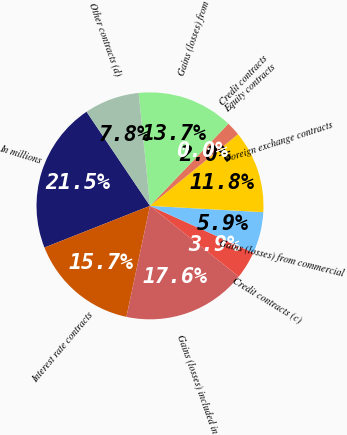Convert chart to OTSL. <chart><loc_0><loc_0><loc_500><loc_500><pie_chart><fcel>In millions<fcel>Interest rate contracts<fcel>Gains (losses) included in<fcel>Credit contracts (c)<fcel>Gains (losses) from commercial<fcel>Foreign exchange contracts<fcel>Equity contracts<fcel>Credit contracts<fcel>Gains (losses) from<fcel>Other contracts (d)<nl><fcel>21.55%<fcel>15.68%<fcel>17.63%<fcel>3.93%<fcel>5.89%<fcel>11.76%<fcel>1.98%<fcel>0.02%<fcel>13.72%<fcel>7.85%<nl></chart> 